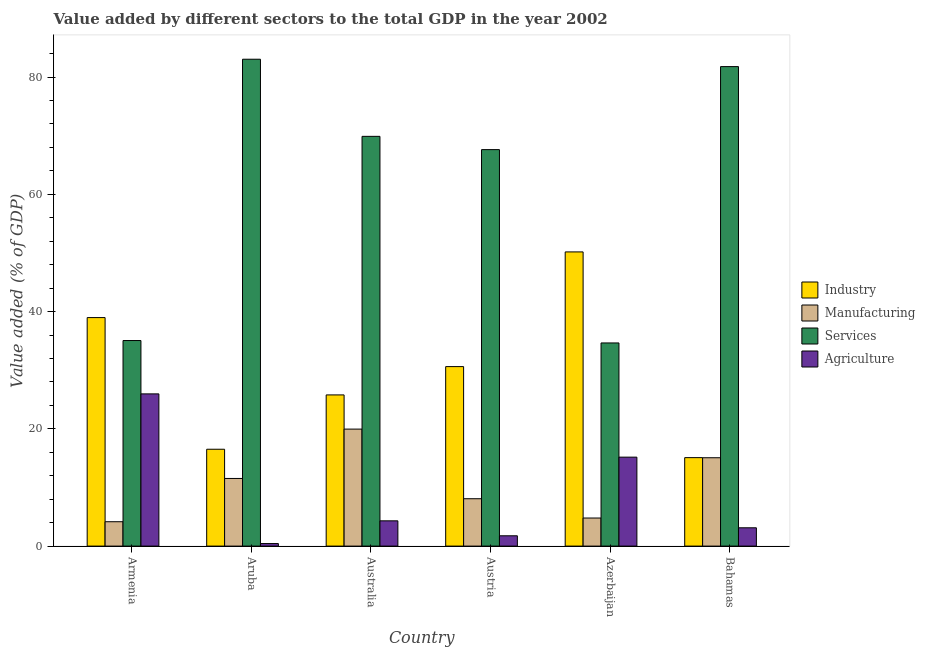How many groups of bars are there?
Offer a very short reply. 6. Are the number of bars per tick equal to the number of legend labels?
Offer a very short reply. Yes. Are the number of bars on each tick of the X-axis equal?
Offer a terse response. Yes. How many bars are there on the 1st tick from the left?
Give a very brief answer. 4. How many bars are there on the 4th tick from the right?
Offer a terse response. 4. What is the label of the 2nd group of bars from the left?
Keep it short and to the point. Aruba. What is the value added by services sector in Armenia?
Keep it short and to the point. 35.06. Across all countries, what is the maximum value added by services sector?
Make the answer very short. 83.04. Across all countries, what is the minimum value added by services sector?
Make the answer very short. 34.65. In which country was the value added by industrial sector minimum?
Ensure brevity in your answer.  Bahamas. What is the total value added by industrial sector in the graph?
Offer a terse response. 177.17. What is the difference between the value added by industrial sector in Austria and that in Bahamas?
Make the answer very short. 15.53. What is the difference between the value added by industrial sector in Australia and the value added by manufacturing sector in Azerbaijan?
Offer a very short reply. 21. What is the average value added by industrial sector per country?
Your answer should be compact. 29.53. What is the difference between the value added by manufacturing sector and value added by services sector in Armenia?
Offer a terse response. -30.9. What is the ratio of the value added by services sector in Armenia to that in Austria?
Keep it short and to the point. 0.52. What is the difference between the highest and the second highest value added by agricultural sector?
Keep it short and to the point. 10.79. What is the difference between the highest and the lowest value added by manufacturing sector?
Provide a short and direct response. 15.8. What does the 1st bar from the left in Austria represents?
Offer a terse response. Industry. What does the 3rd bar from the right in Australia represents?
Make the answer very short. Manufacturing. Is it the case that in every country, the sum of the value added by industrial sector and value added by manufacturing sector is greater than the value added by services sector?
Offer a terse response. No. How many countries are there in the graph?
Keep it short and to the point. 6. Does the graph contain grids?
Give a very brief answer. No. Where does the legend appear in the graph?
Your answer should be very brief. Center right. What is the title of the graph?
Offer a very short reply. Value added by different sectors to the total GDP in the year 2002. Does "Primary education" appear as one of the legend labels in the graph?
Provide a succinct answer. No. What is the label or title of the X-axis?
Keep it short and to the point. Country. What is the label or title of the Y-axis?
Offer a very short reply. Value added (% of GDP). What is the Value added (% of GDP) in Industry in Armenia?
Offer a terse response. 38.98. What is the Value added (% of GDP) in Manufacturing in Armenia?
Offer a terse response. 4.16. What is the Value added (% of GDP) in Services in Armenia?
Offer a terse response. 35.06. What is the Value added (% of GDP) in Agriculture in Armenia?
Your answer should be compact. 25.96. What is the Value added (% of GDP) of Industry in Aruba?
Provide a short and direct response. 16.52. What is the Value added (% of GDP) of Manufacturing in Aruba?
Provide a succinct answer. 11.54. What is the Value added (% of GDP) in Services in Aruba?
Ensure brevity in your answer.  83.04. What is the Value added (% of GDP) of Agriculture in Aruba?
Provide a short and direct response. 0.43. What is the Value added (% of GDP) in Industry in Australia?
Give a very brief answer. 25.79. What is the Value added (% of GDP) of Manufacturing in Australia?
Provide a short and direct response. 19.96. What is the Value added (% of GDP) of Services in Australia?
Provide a succinct answer. 69.89. What is the Value added (% of GDP) in Agriculture in Australia?
Your answer should be very brief. 4.31. What is the Value added (% of GDP) in Industry in Austria?
Your answer should be compact. 30.62. What is the Value added (% of GDP) of Manufacturing in Austria?
Provide a short and direct response. 8.08. What is the Value added (% of GDP) of Services in Austria?
Your answer should be very brief. 67.63. What is the Value added (% of GDP) in Agriculture in Austria?
Offer a terse response. 1.76. What is the Value added (% of GDP) in Industry in Azerbaijan?
Give a very brief answer. 50.18. What is the Value added (% of GDP) in Manufacturing in Azerbaijan?
Make the answer very short. 4.79. What is the Value added (% of GDP) of Services in Azerbaijan?
Your answer should be compact. 34.65. What is the Value added (% of GDP) of Agriculture in Azerbaijan?
Offer a terse response. 15.17. What is the Value added (% of GDP) in Industry in Bahamas?
Give a very brief answer. 15.09. What is the Value added (% of GDP) of Manufacturing in Bahamas?
Ensure brevity in your answer.  15.07. What is the Value added (% of GDP) in Services in Bahamas?
Your response must be concise. 81.79. What is the Value added (% of GDP) of Agriculture in Bahamas?
Provide a short and direct response. 3.12. Across all countries, what is the maximum Value added (% of GDP) of Industry?
Give a very brief answer. 50.18. Across all countries, what is the maximum Value added (% of GDP) in Manufacturing?
Ensure brevity in your answer.  19.96. Across all countries, what is the maximum Value added (% of GDP) of Services?
Offer a terse response. 83.04. Across all countries, what is the maximum Value added (% of GDP) of Agriculture?
Keep it short and to the point. 25.96. Across all countries, what is the minimum Value added (% of GDP) in Industry?
Give a very brief answer. 15.09. Across all countries, what is the minimum Value added (% of GDP) of Manufacturing?
Your answer should be very brief. 4.16. Across all countries, what is the minimum Value added (% of GDP) of Services?
Offer a very short reply. 34.65. Across all countries, what is the minimum Value added (% of GDP) of Agriculture?
Give a very brief answer. 0.43. What is the total Value added (% of GDP) of Industry in the graph?
Your response must be concise. 177.17. What is the total Value added (% of GDP) in Manufacturing in the graph?
Provide a succinct answer. 63.59. What is the total Value added (% of GDP) in Services in the graph?
Offer a terse response. 372.06. What is the total Value added (% of GDP) in Agriculture in the graph?
Your answer should be very brief. 50.76. What is the difference between the Value added (% of GDP) in Industry in Armenia and that in Aruba?
Provide a succinct answer. 22.46. What is the difference between the Value added (% of GDP) in Manufacturing in Armenia and that in Aruba?
Provide a succinct answer. -7.38. What is the difference between the Value added (% of GDP) of Services in Armenia and that in Aruba?
Offer a very short reply. -47.98. What is the difference between the Value added (% of GDP) in Agriculture in Armenia and that in Aruba?
Make the answer very short. 25.53. What is the difference between the Value added (% of GDP) of Industry in Armenia and that in Australia?
Offer a terse response. 13.19. What is the difference between the Value added (% of GDP) in Manufacturing in Armenia and that in Australia?
Offer a very short reply. -15.8. What is the difference between the Value added (% of GDP) in Services in Armenia and that in Australia?
Your response must be concise. -34.83. What is the difference between the Value added (% of GDP) in Agriculture in Armenia and that in Australia?
Make the answer very short. 21.65. What is the difference between the Value added (% of GDP) of Industry in Armenia and that in Austria?
Provide a short and direct response. 8.36. What is the difference between the Value added (% of GDP) in Manufacturing in Armenia and that in Austria?
Keep it short and to the point. -3.92. What is the difference between the Value added (% of GDP) of Services in Armenia and that in Austria?
Offer a very short reply. -32.56. What is the difference between the Value added (% of GDP) in Agriculture in Armenia and that in Austria?
Your answer should be compact. 24.2. What is the difference between the Value added (% of GDP) of Industry in Armenia and that in Azerbaijan?
Offer a terse response. -11.2. What is the difference between the Value added (% of GDP) in Manufacturing in Armenia and that in Azerbaijan?
Offer a terse response. -0.63. What is the difference between the Value added (% of GDP) in Services in Armenia and that in Azerbaijan?
Offer a very short reply. 0.41. What is the difference between the Value added (% of GDP) in Agriculture in Armenia and that in Azerbaijan?
Ensure brevity in your answer.  10.79. What is the difference between the Value added (% of GDP) of Industry in Armenia and that in Bahamas?
Offer a very short reply. 23.89. What is the difference between the Value added (% of GDP) in Manufacturing in Armenia and that in Bahamas?
Provide a succinct answer. -10.91. What is the difference between the Value added (% of GDP) in Services in Armenia and that in Bahamas?
Ensure brevity in your answer.  -46.72. What is the difference between the Value added (% of GDP) in Agriculture in Armenia and that in Bahamas?
Keep it short and to the point. 22.84. What is the difference between the Value added (% of GDP) of Industry in Aruba and that in Australia?
Provide a succinct answer. -9.27. What is the difference between the Value added (% of GDP) of Manufacturing in Aruba and that in Australia?
Provide a succinct answer. -8.42. What is the difference between the Value added (% of GDP) of Services in Aruba and that in Australia?
Give a very brief answer. 13.16. What is the difference between the Value added (% of GDP) of Agriculture in Aruba and that in Australia?
Make the answer very short. -3.87. What is the difference between the Value added (% of GDP) in Industry in Aruba and that in Austria?
Your response must be concise. -14.1. What is the difference between the Value added (% of GDP) of Manufacturing in Aruba and that in Austria?
Offer a terse response. 3.46. What is the difference between the Value added (% of GDP) of Services in Aruba and that in Austria?
Keep it short and to the point. 15.42. What is the difference between the Value added (% of GDP) in Agriculture in Aruba and that in Austria?
Ensure brevity in your answer.  -1.32. What is the difference between the Value added (% of GDP) in Industry in Aruba and that in Azerbaijan?
Provide a short and direct response. -33.66. What is the difference between the Value added (% of GDP) of Manufacturing in Aruba and that in Azerbaijan?
Make the answer very short. 6.75. What is the difference between the Value added (% of GDP) of Services in Aruba and that in Azerbaijan?
Offer a terse response. 48.4. What is the difference between the Value added (% of GDP) of Agriculture in Aruba and that in Azerbaijan?
Keep it short and to the point. -14.74. What is the difference between the Value added (% of GDP) in Industry in Aruba and that in Bahamas?
Provide a succinct answer. 1.43. What is the difference between the Value added (% of GDP) in Manufacturing in Aruba and that in Bahamas?
Provide a succinct answer. -3.53. What is the difference between the Value added (% of GDP) of Services in Aruba and that in Bahamas?
Make the answer very short. 1.26. What is the difference between the Value added (% of GDP) in Agriculture in Aruba and that in Bahamas?
Your answer should be compact. -2.69. What is the difference between the Value added (% of GDP) in Industry in Australia and that in Austria?
Offer a very short reply. -4.83. What is the difference between the Value added (% of GDP) of Manufacturing in Australia and that in Austria?
Offer a terse response. 11.88. What is the difference between the Value added (% of GDP) in Services in Australia and that in Austria?
Provide a succinct answer. 2.26. What is the difference between the Value added (% of GDP) of Agriculture in Australia and that in Austria?
Offer a terse response. 2.55. What is the difference between the Value added (% of GDP) of Industry in Australia and that in Azerbaijan?
Make the answer very short. -24.39. What is the difference between the Value added (% of GDP) of Manufacturing in Australia and that in Azerbaijan?
Make the answer very short. 15.17. What is the difference between the Value added (% of GDP) in Services in Australia and that in Azerbaijan?
Your answer should be very brief. 35.24. What is the difference between the Value added (% of GDP) in Agriculture in Australia and that in Azerbaijan?
Offer a terse response. -10.86. What is the difference between the Value added (% of GDP) in Industry in Australia and that in Bahamas?
Your response must be concise. 10.7. What is the difference between the Value added (% of GDP) in Manufacturing in Australia and that in Bahamas?
Your answer should be very brief. 4.88. What is the difference between the Value added (% of GDP) of Services in Australia and that in Bahamas?
Give a very brief answer. -11.9. What is the difference between the Value added (% of GDP) of Agriculture in Australia and that in Bahamas?
Your response must be concise. 1.19. What is the difference between the Value added (% of GDP) of Industry in Austria and that in Azerbaijan?
Keep it short and to the point. -19.56. What is the difference between the Value added (% of GDP) of Manufacturing in Austria and that in Azerbaijan?
Provide a succinct answer. 3.29. What is the difference between the Value added (% of GDP) in Services in Austria and that in Azerbaijan?
Your answer should be compact. 32.98. What is the difference between the Value added (% of GDP) of Agriculture in Austria and that in Azerbaijan?
Offer a terse response. -13.41. What is the difference between the Value added (% of GDP) in Industry in Austria and that in Bahamas?
Your answer should be very brief. 15.53. What is the difference between the Value added (% of GDP) of Manufacturing in Austria and that in Bahamas?
Give a very brief answer. -6.99. What is the difference between the Value added (% of GDP) of Services in Austria and that in Bahamas?
Give a very brief answer. -14.16. What is the difference between the Value added (% of GDP) in Agriculture in Austria and that in Bahamas?
Provide a succinct answer. -1.37. What is the difference between the Value added (% of GDP) of Industry in Azerbaijan and that in Bahamas?
Offer a very short reply. 35.09. What is the difference between the Value added (% of GDP) in Manufacturing in Azerbaijan and that in Bahamas?
Your response must be concise. -10.28. What is the difference between the Value added (% of GDP) in Services in Azerbaijan and that in Bahamas?
Provide a short and direct response. -47.14. What is the difference between the Value added (% of GDP) in Agriculture in Azerbaijan and that in Bahamas?
Offer a very short reply. 12.05. What is the difference between the Value added (% of GDP) of Industry in Armenia and the Value added (% of GDP) of Manufacturing in Aruba?
Provide a succinct answer. 27.44. What is the difference between the Value added (% of GDP) of Industry in Armenia and the Value added (% of GDP) of Services in Aruba?
Provide a short and direct response. -44.07. What is the difference between the Value added (% of GDP) in Industry in Armenia and the Value added (% of GDP) in Agriculture in Aruba?
Offer a very short reply. 38.54. What is the difference between the Value added (% of GDP) of Manufacturing in Armenia and the Value added (% of GDP) of Services in Aruba?
Your answer should be compact. -78.89. What is the difference between the Value added (% of GDP) of Manufacturing in Armenia and the Value added (% of GDP) of Agriculture in Aruba?
Your answer should be compact. 3.72. What is the difference between the Value added (% of GDP) in Services in Armenia and the Value added (% of GDP) in Agriculture in Aruba?
Give a very brief answer. 34.63. What is the difference between the Value added (% of GDP) of Industry in Armenia and the Value added (% of GDP) of Manufacturing in Australia?
Your answer should be very brief. 19.02. What is the difference between the Value added (% of GDP) in Industry in Armenia and the Value added (% of GDP) in Services in Australia?
Keep it short and to the point. -30.91. What is the difference between the Value added (% of GDP) in Industry in Armenia and the Value added (% of GDP) in Agriculture in Australia?
Offer a very short reply. 34.67. What is the difference between the Value added (% of GDP) of Manufacturing in Armenia and the Value added (% of GDP) of Services in Australia?
Your answer should be very brief. -65.73. What is the difference between the Value added (% of GDP) in Manufacturing in Armenia and the Value added (% of GDP) in Agriculture in Australia?
Make the answer very short. -0.15. What is the difference between the Value added (% of GDP) of Services in Armenia and the Value added (% of GDP) of Agriculture in Australia?
Offer a very short reply. 30.75. What is the difference between the Value added (% of GDP) of Industry in Armenia and the Value added (% of GDP) of Manufacturing in Austria?
Ensure brevity in your answer.  30.9. What is the difference between the Value added (% of GDP) in Industry in Armenia and the Value added (% of GDP) in Services in Austria?
Offer a very short reply. -28.65. What is the difference between the Value added (% of GDP) of Industry in Armenia and the Value added (% of GDP) of Agriculture in Austria?
Offer a terse response. 37.22. What is the difference between the Value added (% of GDP) in Manufacturing in Armenia and the Value added (% of GDP) in Services in Austria?
Offer a terse response. -63.47. What is the difference between the Value added (% of GDP) of Manufacturing in Armenia and the Value added (% of GDP) of Agriculture in Austria?
Make the answer very short. 2.4. What is the difference between the Value added (% of GDP) of Services in Armenia and the Value added (% of GDP) of Agriculture in Austria?
Provide a short and direct response. 33.3. What is the difference between the Value added (% of GDP) of Industry in Armenia and the Value added (% of GDP) of Manufacturing in Azerbaijan?
Offer a very short reply. 34.19. What is the difference between the Value added (% of GDP) of Industry in Armenia and the Value added (% of GDP) of Services in Azerbaijan?
Make the answer very short. 4.33. What is the difference between the Value added (% of GDP) of Industry in Armenia and the Value added (% of GDP) of Agriculture in Azerbaijan?
Make the answer very short. 23.8. What is the difference between the Value added (% of GDP) in Manufacturing in Armenia and the Value added (% of GDP) in Services in Azerbaijan?
Your answer should be very brief. -30.49. What is the difference between the Value added (% of GDP) in Manufacturing in Armenia and the Value added (% of GDP) in Agriculture in Azerbaijan?
Provide a short and direct response. -11.01. What is the difference between the Value added (% of GDP) of Services in Armenia and the Value added (% of GDP) of Agriculture in Azerbaijan?
Offer a terse response. 19.89. What is the difference between the Value added (% of GDP) of Industry in Armenia and the Value added (% of GDP) of Manufacturing in Bahamas?
Your answer should be very brief. 23.9. What is the difference between the Value added (% of GDP) in Industry in Armenia and the Value added (% of GDP) in Services in Bahamas?
Your response must be concise. -42.81. What is the difference between the Value added (% of GDP) in Industry in Armenia and the Value added (% of GDP) in Agriculture in Bahamas?
Keep it short and to the point. 35.85. What is the difference between the Value added (% of GDP) in Manufacturing in Armenia and the Value added (% of GDP) in Services in Bahamas?
Provide a succinct answer. -77.63. What is the difference between the Value added (% of GDP) of Manufacturing in Armenia and the Value added (% of GDP) of Agriculture in Bahamas?
Give a very brief answer. 1.03. What is the difference between the Value added (% of GDP) of Services in Armenia and the Value added (% of GDP) of Agriculture in Bahamas?
Your response must be concise. 31.94. What is the difference between the Value added (% of GDP) of Industry in Aruba and the Value added (% of GDP) of Manufacturing in Australia?
Offer a terse response. -3.44. What is the difference between the Value added (% of GDP) of Industry in Aruba and the Value added (% of GDP) of Services in Australia?
Give a very brief answer. -53.37. What is the difference between the Value added (% of GDP) in Industry in Aruba and the Value added (% of GDP) in Agriculture in Australia?
Your answer should be compact. 12.21. What is the difference between the Value added (% of GDP) of Manufacturing in Aruba and the Value added (% of GDP) of Services in Australia?
Keep it short and to the point. -58.35. What is the difference between the Value added (% of GDP) in Manufacturing in Aruba and the Value added (% of GDP) in Agriculture in Australia?
Your answer should be very brief. 7.23. What is the difference between the Value added (% of GDP) in Services in Aruba and the Value added (% of GDP) in Agriculture in Australia?
Provide a short and direct response. 78.74. What is the difference between the Value added (% of GDP) of Industry in Aruba and the Value added (% of GDP) of Manufacturing in Austria?
Provide a short and direct response. 8.44. What is the difference between the Value added (% of GDP) in Industry in Aruba and the Value added (% of GDP) in Services in Austria?
Offer a terse response. -51.11. What is the difference between the Value added (% of GDP) in Industry in Aruba and the Value added (% of GDP) in Agriculture in Austria?
Your answer should be compact. 14.76. What is the difference between the Value added (% of GDP) of Manufacturing in Aruba and the Value added (% of GDP) of Services in Austria?
Your response must be concise. -56.09. What is the difference between the Value added (% of GDP) of Manufacturing in Aruba and the Value added (% of GDP) of Agriculture in Austria?
Make the answer very short. 9.78. What is the difference between the Value added (% of GDP) of Services in Aruba and the Value added (% of GDP) of Agriculture in Austria?
Keep it short and to the point. 81.29. What is the difference between the Value added (% of GDP) of Industry in Aruba and the Value added (% of GDP) of Manufacturing in Azerbaijan?
Ensure brevity in your answer.  11.73. What is the difference between the Value added (% of GDP) in Industry in Aruba and the Value added (% of GDP) in Services in Azerbaijan?
Offer a terse response. -18.13. What is the difference between the Value added (% of GDP) in Industry in Aruba and the Value added (% of GDP) in Agriculture in Azerbaijan?
Provide a succinct answer. 1.35. What is the difference between the Value added (% of GDP) in Manufacturing in Aruba and the Value added (% of GDP) in Services in Azerbaijan?
Offer a terse response. -23.11. What is the difference between the Value added (% of GDP) of Manufacturing in Aruba and the Value added (% of GDP) of Agriculture in Azerbaijan?
Your answer should be very brief. -3.63. What is the difference between the Value added (% of GDP) in Services in Aruba and the Value added (% of GDP) in Agriculture in Azerbaijan?
Ensure brevity in your answer.  67.87. What is the difference between the Value added (% of GDP) of Industry in Aruba and the Value added (% of GDP) of Manufacturing in Bahamas?
Provide a short and direct response. 1.45. What is the difference between the Value added (% of GDP) in Industry in Aruba and the Value added (% of GDP) in Services in Bahamas?
Provide a short and direct response. -65.27. What is the difference between the Value added (% of GDP) of Industry in Aruba and the Value added (% of GDP) of Agriculture in Bahamas?
Provide a short and direct response. 13.4. What is the difference between the Value added (% of GDP) of Manufacturing in Aruba and the Value added (% of GDP) of Services in Bahamas?
Your answer should be compact. -70.25. What is the difference between the Value added (% of GDP) in Manufacturing in Aruba and the Value added (% of GDP) in Agriculture in Bahamas?
Ensure brevity in your answer.  8.41. What is the difference between the Value added (% of GDP) of Services in Aruba and the Value added (% of GDP) of Agriculture in Bahamas?
Your response must be concise. 79.92. What is the difference between the Value added (% of GDP) of Industry in Australia and the Value added (% of GDP) of Manufacturing in Austria?
Provide a short and direct response. 17.71. What is the difference between the Value added (% of GDP) of Industry in Australia and the Value added (% of GDP) of Services in Austria?
Ensure brevity in your answer.  -41.84. What is the difference between the Value added (% of GDP) in Industry in Australia and the Value added (% of GDP) in Agriculture in Austria?
Your answer should be very brief. 24.03. What is the difference between the Value added (% of GDP) in Manufacturing in Australia and the Value added (% of GDP) in Services in Austria?
Ensure brevity in your answer.  -47.67. What is the difference between the Value added (% of GDP) in Manufacturing in Australia and the Value added (% of GDP) in Agriculture in Austria?
Your answer should be very brief. 18.2. What is the difference between the Value added (% of GDP) in Services in Australia and the Value added (% of GDP) in Agriculture in Austria?
Offer a very short reply. 68.13. What is the difference between the Value added (% of GDP) in Industry in Australia and the Value added (% of GDP) in Manufacturing in Azerbaijan?
Ensure brevity in your answer.  21. What is the difference between the Value added (% of GDP) of Industry in Australia and the Value added (% of GDP) of Services in Azerbaijan?
Provide a short and direct response. -8.86. What is the difference between the Value added (% of GDP) in Industry in Australia and the Value added (% of GDP) in Agriculture in Azerbaijan?
Make the answer very short. 10.61. What is the difference between the Value added (% of GDP) in Manufacturing in Australia and the Value added (% of GDP) in Services in Azerbaijan?
Your answer should be compact. -14.69. What is the difference between the Value added (% of GDP) of Manufacturing in Australia and the Value added (% of GDP) of Agriculture in Azerbaijan?
Your answer should be compact. 4.78. What is the difference between the Value added (% of GDP) of Services in Australia and the Value added (% of GDP) of Agriculture in Azerbaijan?
Your answer should be very brief. 54.72. What is the difference between the Value added (% of GDP) in Industry in Australia and the Value added (% of GDP) in Manufacturing in Bahamas?
Make the answer very short. 10.71. What is the difference between the Value added (% of GDP) in Industry in Australia and the Value added (% of GDP) in Services in Bahamas?
Provide a short and direct response. -56. What is the difference between the Value added (% of GDP) of Industry in Australia and the Value added (% of GDP) of Agriculture in Bahamas?
Your answer should be compact. 22.66. What is the difference between the Value added (% of GDP) of Manufacturing in Australia and the Value added (% of GDP) of Services in Bahamas?
Offer a terse response. -61.83. What is the difference between the Value added (% of GDP) of Manufacturing in Australia and the Value added (% of GDP) of Agriculture in Bahamas?
Make the answer very short. 16.83. What is the difference between the Value added (% of GDP) of Services in Australia and the Value added (% of GDP) of Agriculture in Bahamas?
Give a very brief answer. 66.77. What is the difference between the Value added (% of GDP) in Industry in Austria and the Value added (% of GDP) in Manufacturing in Azerbaijan?
Make the answer very short. 25.83. What is the difference between the Value added (% of GDP) of Industry in Austria and the Value added (% of GDP) of Services in Azerbaijan?
Provide a succinct answer. -4.03. What is the difference between the Value added (% of GDP) of Industry in Austria and the Value added (% of GDP) of Agriculture in Azerbaijan?
Your answer should be compact. 15.44. What is the difference between the Value added (% of GDP) in Manufacturing in Austria and the Value added (% of GDP) in Services in Azerbaijan?
Give a very brief answer. -26.57. What is the difference between the Value added (% of GDP) in Manufacturing in Austria and the Value added (% of GDP) in Agriculture in Azerbaijan?
Provide a short and direct response. -7.09. What is the difference between the Value added (% of GDP) of Services in Austria and the Value added (% of GDP) of Agriculture in Azerbaijan?
Provide a short and direct response. 52.45. What is the difference between the Value added (% of GDP) in Industry in Austria and the Value added (% of GDP) in Manufacturing in Bahamas?
Provide a succinct answer. 15.54. What is the difference between the Value added (% of GDP) of Industry in Austria and the Value added (% of GDP) of Services in Bahamas?
Offer a terse response. -51.17. What is the difference between the Value added (% of GDP) in Industry in Austria and the Value added (% of GDP) in Agriculture in Bahamas?
Keep it short and to the point. 27.49. What is the difference between the Value added (% of GDP) of Manufacturing in Austria and the Value added (% of GDP) of Services in Bahamas?
Provide a succinct answer. -73.71. What is the difference between the Value added (% of GDP) of Manufacturing in Austria and the Value added (% of GDP) of Agriculture in Bahamas?
Keep it short and to the point. 4.96. What is the difference between the Value added (% of GDP) in Services in Austria and the Value added (% of GDP) in Agriculture in Bahamas?
Make the answer very short. 64.5. What is the difference between the Value added (% of GDP) in Industry in Azerbaijan and the Value added (% of GDP) in Manufacturing in Bahamas?
Keep it short and to the point. 35.11. What is the difference between the Value added (% of GDP) of Industry in Azerbaijan and the Value added (% of GDP) of Services in Bahamas?
Make the answer very short. -31.61. What is the difference between the Value added (% of GDP) in Industry in Azerbaijan and the Value added (% of GDP) in Agriculture in Bahamas?
Your answer should be very brief. 47.05. What is the difference between the Value added (% of GDP) of Manufacturing in Azerbaijan and the Value added (% of GDP) of Services in Bahamas?
Your answer should be very brief. -77. What is the difference between the Value added (% of GDP) in Manufacturing in Azerbaijan and the Value added (% of GDP) in Agriculture in Bahamas?
Give a very brief answer. 1.67. What is the difference between the Value added (% of GDP) of Services in Azerbaijan and the Value added (% of GDP) of Agriculture in Bahamas?
Your answer should be very brief. 31.53. What is the average Value added (% of GDP) of Industry per country?
Offer a terse response. 29.53. What is the average Value added (% of GDP) in Manufacturing per country?
Provide a succinct answer. 10.6. What is the average Value added (% of GDP) in Services per country?
Provide a short and direct response. 62.01. What is the average Value added (% of GDP) of Agriculture per country?
Offer a terse response. 8.46. What is the difference between the Value added (% of GDP) of Industry and Value added (% of GDP) of Manufacturing in Armenia?
Provide a short and direct response. 34.82. What is the difference between the Value added (% of GDP) of Industry and Value added (% of GDP) of Services in Armenia?
Provide a short and direct response. 3.91. What is the difference between the Value added (% of GDP) of Industry and Value added (% of GDP) of Agriculture in Armenia?
Ensure brevity in your answer.  13.01. What is the difference between the Value added (% of GDP) in Manufacturing and Value added (% of GDP) in Services in Armenia?
Give a very brief answer. -30.9. What is the difference between the Value added (% of GDP) of Manufacturing and Value added (% of GDP) of Agriculture in Armenia?
Ensure brevity in your answer.  -21.8. What is the difference between the Value added (% of GDP) in Services and Value added (% of GDP) in Agriculture in Armenia?
Offer a very short reply. 9.1. What is the difference between the Value added (% of GDP) of Industry and Value added (% of GDP) of Manufacturing in Aruba?
Your answer should be compact. 4.98. What is the difference between the Value added (% of GDP) of Industry and Value added (% of GDP) of Services in Aruba?
Give a very brief answer. -66.52. What is the difference between the Value added (% of GDP) of Industry and Value added (% of GDP) of Agriculture in Aruba?
Provide a succinct answer. 16.09. What is the difference between the Value added (% of GDP) of Manufacturing and Value added (% of GDP) of Services in Aruba?
Offer a terse response. -71.51. What is the difference between the Value added (% of GDP) in Manufacturing and Value added (% of GDP) in Agriculture in Aruba?
Your answer should be very brief. 11.1. What is the difference between the Value added (% of GDP) of Services and Value added (% of GDP) of Agriculture in Aruba?
Provide a succinct answer. 82.61. What is the difference between the Value added (% of GDP) in Industry and Value added (% of GDP) in Manufacturing in Australia?
Your answer should be compact. 5.83. What is the difference between the Value added (% of GDP) of Industry and Value added (% of GDP) of Services in Australia?
Keep it short and to the point. -44.1. What is the difference between the Value added (% of GDP) in Industry and Value added (% of GDP) in Agriculture in Australia?
Give a very brief answer. 21.48. What is the difference between the Value added (% of GDP) in Manufacturing and Value added (% of GDP) in Services in Australia?
Your response must be concise. -49.93. What is the difference between the Value added (% of GDP) of Manufacturing and Value added (% of GDP) of Agriculture in Australia?
Provide a succinct answer. 15.65. What is the difference between the Value added (% of GDP) in Services and Value added (% of GDP) in Agriculture in Australia?
Ensure brevity in your answer.  65.58. What is the difference between the Value added (% of GDP) of Industry and Value added (% of GDP) of Manufacturing in Austria?
Give a very brief answer. 22.54. What is the difference between the Value added (% of GDP) of Industry and Value added (% of GDP) of Services in Austria?
Provide a succinct answer. -37.01. What is the difference between the Value added (% of GDP) of Industry and Value added (% of GDP) of Agriculture in Austria?
Offer a terse response. 28.86. What is the difference between the Value added (% of GDP) of Manufacturing and Value added (% of GDP) of Services in Austria?
Your answer should be compact. -59.55. What is the difference between the Value added (% of GDP) in Manufacturing and Value added (% of GDP) in Agriculture in Austria?
Make the answer very short. 6.32. What is the difference between the Value added (% of GDP) of Services and Value added (% of GDP) of Agriculture in Austria?
Your answer should be compact. 65.87. What is the difference between the Value added (% of GDP) in Industry and Value added (% of GDP) in Manufacturing in Azerbaijan?
Offer a terse response. 45.39. What is the difference between the Value added (% of GDP) of Industry and Value added (% of GDP) of Services in Azerbaijan?
Your answer should be very brief. 15.53. What is the difference between the Value added (% of GDP) of Industry and Value added (% of GDP) of Agriculture in Azerbaijan?
Ensure brevity in your answer.  35.01. What is the difference between the Value added (% of GDP) of Manufacturing and Value added (% of GDP) of Services in Azerbaijan?
Your answer should be very brief. -29.86. What is the difference between the Value added (% of GDP) of Manufacturing and Value added (% of GDP) of Agriculture in Azerbaijan?
Offer a terse response. -10.38. What is the difference between the Value added (% of GDP) in Services and Value added (% of GDP) in Agriculture in Azerbaijan?
Make the answer very short. 19.48. What is the difference between the Value added (% of GDP) of Industry and Value added (% of GDP) of Manufacturing in Bahamas?
Your answer should be compact. 0.02. What is the difference between the Value added (% of GDP) in Industry and Value added (% of GDP) in Services in Bahamas?
Offer a terse response. -66.7. What is the difference between the Value added (% of GDP) in Industry and Value added (% of GDP) in Agriculture in Bahamas?
Give a very brief answer. 11.97. What is the difference between the Value added (% of GDP) in Manufacturing and Value added (% of GDP) in Services in Bahamas?
Offer a terse response. -66.71. What is the difference between the Value added (% of GDP) of Manufacturing and Value added (% of GDP) of Agriculture in Bahamas?
Ensure brevity in your answer.  11.95. What is the difference between the Value added (% of GDP) in Services and Value added (% of GDP) in Agriculture in Bahamas?
Your answer should be very brief. 78.66. What is the ratio of the Value added (% of GDP) of Industry in Armenia to that in Aruba?
Provide a short and direct response. 2.36. What is the ratio of the Value added (% of GDP) of Manufacturing in Armenia to that in Aruba?
Your answer should be compact. 0.36. What is the ratio of the Value added (% of GDP) in Services in Armenia to that in Aruba?
Ensure brevity in your answer.  0.42. What is the ratio of the Value added (% of GDP) in Agriculture in Armenia to that in Aruba?
Make the answer very short. 59.72. What is the ratio of the Value added (% of GDP) in Industry in Armenia to that in Australia?
Provide a succinct answer. 1.51. What is the ratio of the Value added (% of GDP) of Manufacturing in Armenia to that in Australia?
Keep it short and to the point. 0.21. What is the ratio of the Value added (% of GDP) of Services in Armenia to that in Australia?
Your answer should be compact. 0.5. What is the ratio of the Value added (% of GDP) in Agriculture in Armenia to that in Australia?
Offer a very short reply. 6.02. What is the ratio of the Value added (% of GDP) of Industry in Armenia to that in Austria?
Your answer should be very brief. 1.27. What is the ratio of the Value added (% of GDP) of Manufacturing in Armenia to that in Austria?
Provide a succinct answer. 0.51. What is the ratio of the Value added (% of GDP) in Services in Armenia to that in Austria?
Offer a very short reply. 0.52. What is the ratio of the Value added (% of GDP) in Agriculture in Armenia to that in Austria?
Ensure brevity in your answer.  14.77. What is the ratio of the Value added (% of GDP) in Industry in Armenia to that in Azerbaijan?
Provide a succinct answer. 0.78. What is the ratio of the Value added (% of GDP) in Manufacturing in Armenia to that in Azerbaijan?
Keep it short and to the point. 0.87. What is the ratio of the Value added (% of GDP) in Services in Armenia to that in Azerbaijan?
Provide a succinct answer. 1.01. What is the ratio of the Value added (% of GDP) of Agriculture in Armenia to that in Azerbaijan?
Provide a short and direct response. 1.71. What is the ratio of the Value added (% of GDP) in Industry in Armenia to that in Bahamas?
Your answer should be very brief. 2.58. What is the ratio of the Value added (% of GDP) in Manufacturing in Armenia to that in Bahamas?
Provide a succinct answer. 0.28. What is the ratio of the Value added (% of GDP) of Services in Armenia to that in Bahamas?
Your response must be concise. 0.43. What is the ratio of the Value added (% of GDP) of Agriculture in Armenia to that in Bahamas?
Provide a short and direct response. 8.31. What is the ratio of the Value added (% of GDP) of Industry in Aruba to that in Australia?
Provide a short and direct response. 0.64. What is the ratio of the Value added (% of GDP) in Manufacturing in Aruba to that in Australia?
Make the answer very short. 0.58. What is the ratio of the Value added (% of GDP) in Services in Aruba to that in Australia?
Offer a very short reply. 1.19. What is the ratio of the Value added (% of GDP) in Agriculture in Aruba to that in Australia?
Give a very brief answer. 0.1. What is the ratio of the Value added (% of GDP) of Industry in Aruba to that in Austria?
Your response must be concise. 0.54. What is the ratio of the Value added (% of GDP) of Manufacturing in Aruba to that in Austria?
Provide a short and direct response. 1.43. What is the ratio of the Value added (% of GDP) in Services in Aruba to that in Austria?
Your answer should be compact. 1.23. What is the ratio of the Value added (% of GDP) in Agriculture in Aruba to that in Austria?
Give a very brief answer. 0.25. What is the ratio of the Value added (% of GDP) in Industry in Aruba to that in Azerbaijan?
Offer a very short reply. 0.33. What is the ratio of the Value added (% of GDP) in Manufacturing in Aruba to that in Azerbaijan?
Your answer should be very brief. 2.41. What is the ratio of the Value added (% of GDP) in Services in Aruba to that in Azerbaijan?
Keep it short and to the point. 2.4. What is the ratio of the Value added (% of GDP) of Agriculture in Aruba to that in Azerbaijan?
Your answer should be very brief. 0.03. What is the ratio of the Value added (% of GDP) in Industry in Aruba to that in Bahamas?
Offer a very short reply. 1.09. What is the ratio of the Value added (% of GDP) of Manufacturing in Aruba to that in Bahamas?
Keep it short and to the point. 0.77. What is the ratio of the Value added (% of GDP) in Services in Aruba to that in Bahamas?
Offer a terse response. 1.02. What is the ratio of the Value added (% of GDP) of Agriculture in Aruba to that in Bahamas?
Your answer should be compact. 0.14. What is the ratio of the Value added (% of GDP) of Industry in Australia to that in Austria?
Your answer should be compact. 0.84. What is the ratio of the Value added (% of GDP) in Manufacturing in Australia to that in Austria?
Offer a very short reply. 2.47. What is the ratio of the Value added (% of GDP) of Services in Australia to that in Austria?
Make the answer very short. 1.03. What is the ratio of the Value added (% of GDP) in Agriculture in Australia to that in Austria?
Offer a terse response. 2.45. What is the ratio of the Value added (% of GDP) of Industry in Australia to that in Azerbaijan?
Your answer should be very brief. 0.51. What is the ratio of the Value added (% of GDP) in Manufacturing in Australia to that in Azerbaijan?
Ensure brevity in your answer.  4.17. What is the ratio of the Value added (% of GDP) in Services in Australia to that in Azerbaijan?
Give a very brief answer. 2.02. What is the ratio of the Value added (% of GDP) in Agriculture in Australia to that in Azerbaijan?
Your response must be concise. 0.28. What is the ratio of the Value added (% of GDP) of Industry in Australia to that in Bahamas?
Your answer should be compact. 1.71. What is the ratio of the Value added (% of GDP) in Manufacturing in Australia to that in Bahamas?
Provide a succinct answer. 1.32. What is the ratio of the Value added (% of GDP) of Services in Australia to that in Bahamas?
Offer a terse response. 0.85. What is the ratio of the Value added (% of GDP) of Agriculture in Australia to that in Bahamas?
Provide a succinct answer. 1.38. What is the ratio of the Value added (% of GDP) in Industry in Austria to that in Azerbaijan?
Make the answer very short. 0.61. What is the ratio of the Value added (% of GDP) of Manufacturing in Austria to that in Azerbaijan?
Offer a terse response. 1.69. What is the ratio of the Value added (% of GDP) of Services in Austria to that in Azerbaijan?
Provide a short and direct response. 1.95. What is the ratio of the Value added (% of GDP) in Agriculture in Austria to that in Azerbaijan?
Offer a very short reply. 0.12. What is the ratio of the Value added (% of GDP) of Industry in Austria to that in Bahamas?
Give a very brief answer. 2.03. What is the ratio of the Value added (% of GDP) in Manufacturing in Austria to that in Bahamas?
Offer a terse response. 0.54. What is the ratio of the Value added (% of GDP) in Services in Austria to that in Bahamas?
Your answer should be very brief. 0.83. What is the ratio of the Value added (% of GDP) of Agriculture in Austria to that in Bahamas?
Provide a short and direct response. 0.56. What is the ratio of the Value added (% of GDP) in Industry in Azerbaijan to that in Bahamas?
Provide a short and direct response. 3.33. What is the ratio of the Value added (% of GDP) of Manufacturing in Azerbaijan to that in Bahamas?
Give a very brief answer. 0.32. What is the ratio of the Value added (% of GDP) of Services in Azerbaijan to that in Bahamas?
Make the answer very short. 0.42. What is the ratio of the Value added (% of GDP) of Agriculture in Azerbaijan to that in Bahamas?
Your answer should be compact. 4.86. What is the difference between the highest and the second highest Value added (% of GDP) of Industry?
Ensure brevity in your answer.  11.2. What is the difference between the highest and the second highest Value added (% of GDP) in Manufacturing?
Your answer should be very brief. 4.88. What is the difference between the highest and the second highest Value added (% of GDP) in Services?
Make the answer very short. 1.26. What is the difference between the highest and the second highest Value added (% of GDP) in Agriculture?
Your answer should be very brief. 10.79. What is the difference between the highest and the lowest Value added (% of GDP) in Industry?
Provide a short and direct response. 35.09. What is the difference between the highest and the lowest Value added (% of GDP) in Manufacturing?
Your response must be concise. 15.8. What is the difference between the highest and the lowest Value added (% of GDP) in Services?
Your answer should be compact. 48.4. What is the difference between the highest and the lowest Value added (% of GDP) of Agriculture?
Make the answer very short. 25.53. 